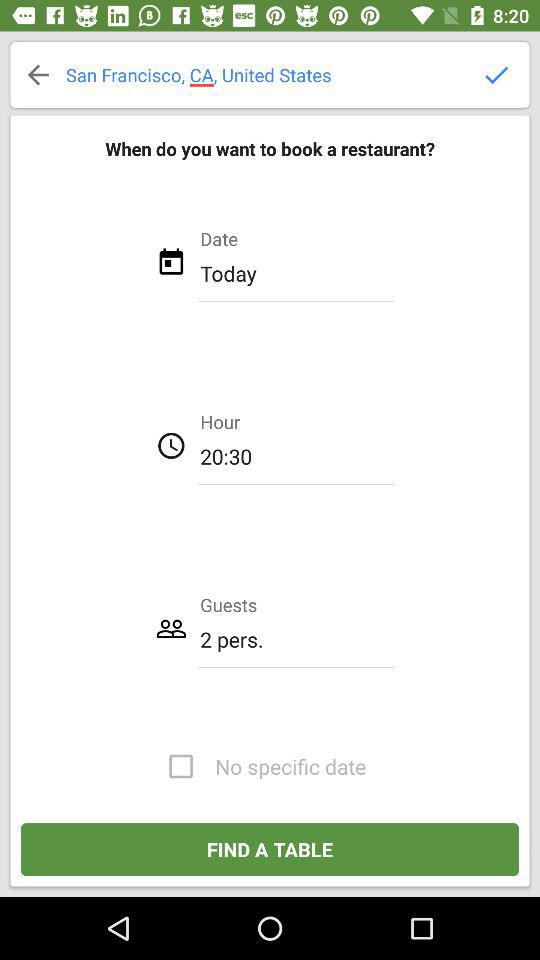For which date can the restaurant be booked? The restaurant can be booked for today. 